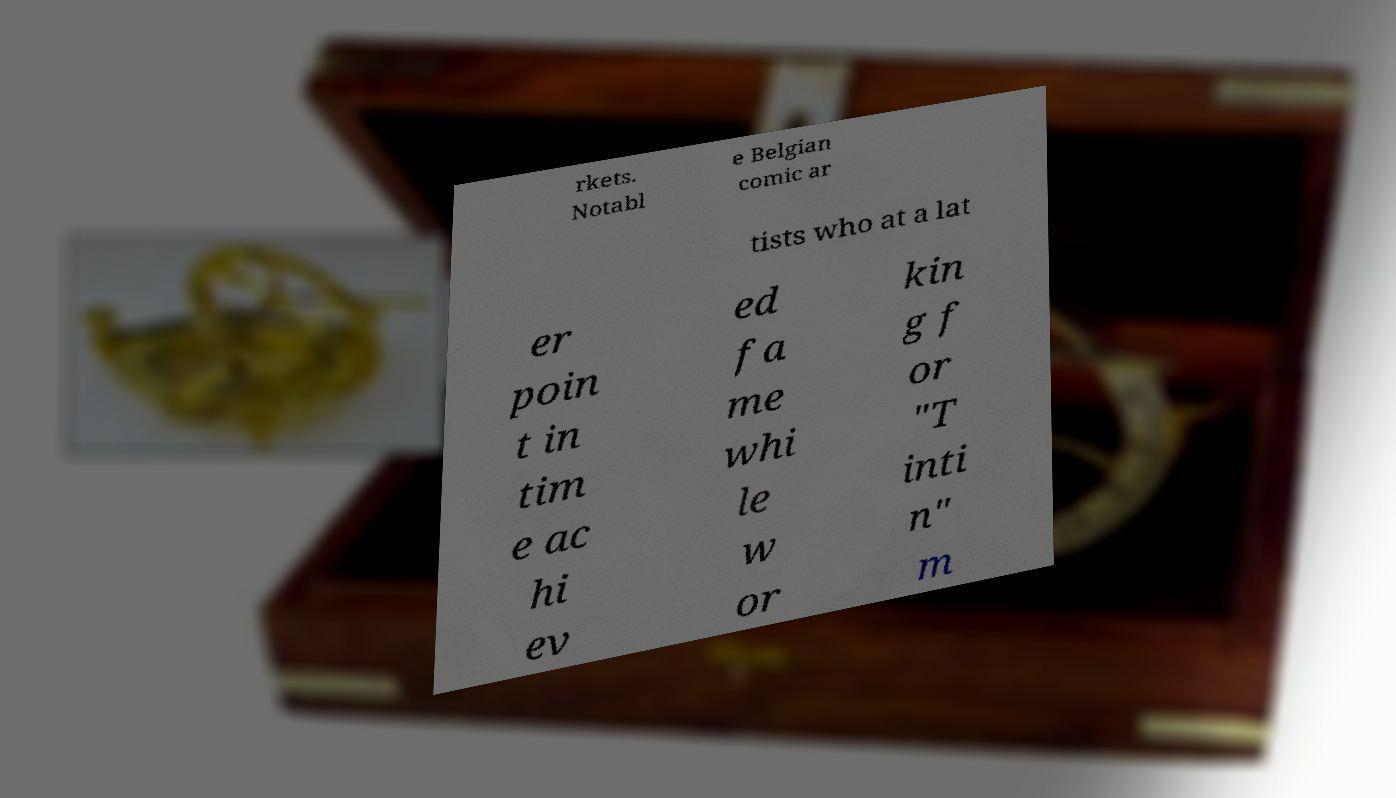Could you extract and type out the text from this image? rkets. Notabl e Belgian comic ar tists who at a lat er poin t in tim e ac hi ev ed fa me whi le w or kin g f or "T inti n" m 